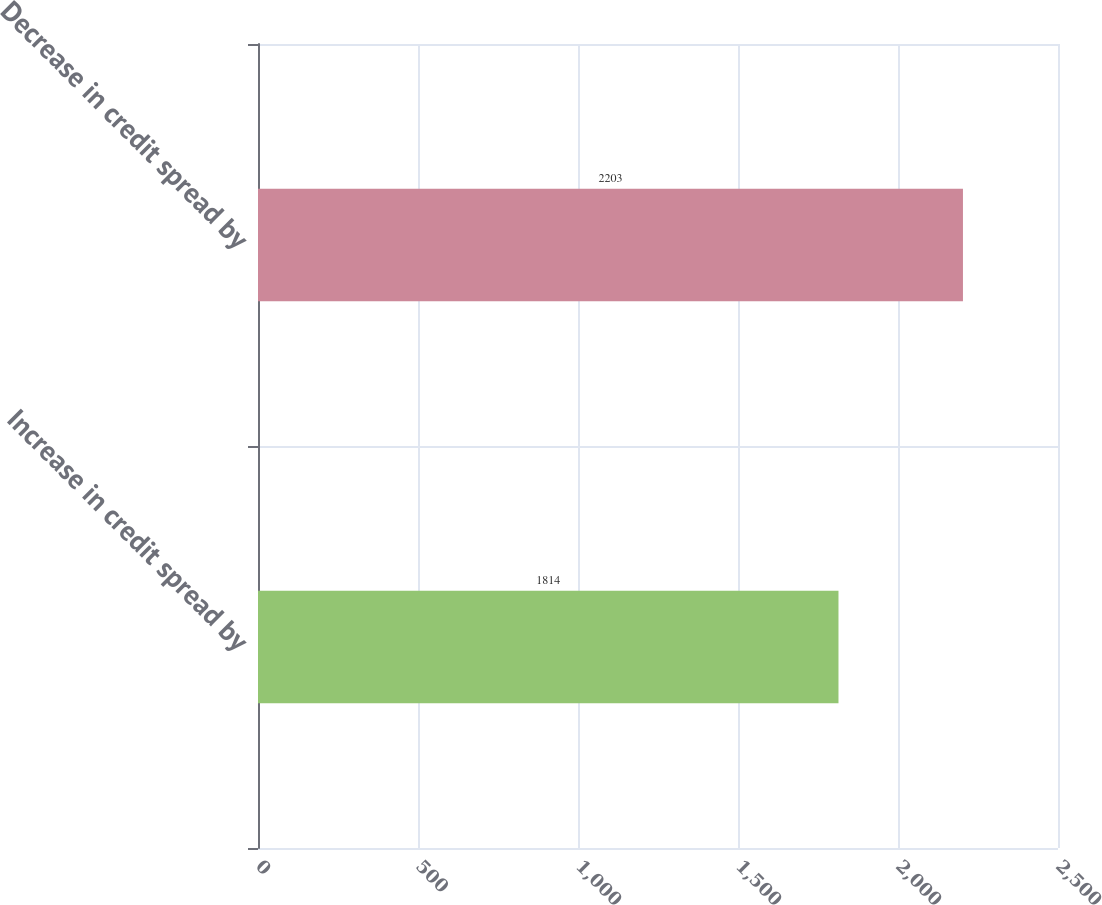<chart> <loc_0><loc_0><loc_500><loc_500><bar_chart><fcel>Increase in credit spread by<fcel>Decrease in credit spread by<nl><fcel>1814<fcel>2203<nl></chart> 